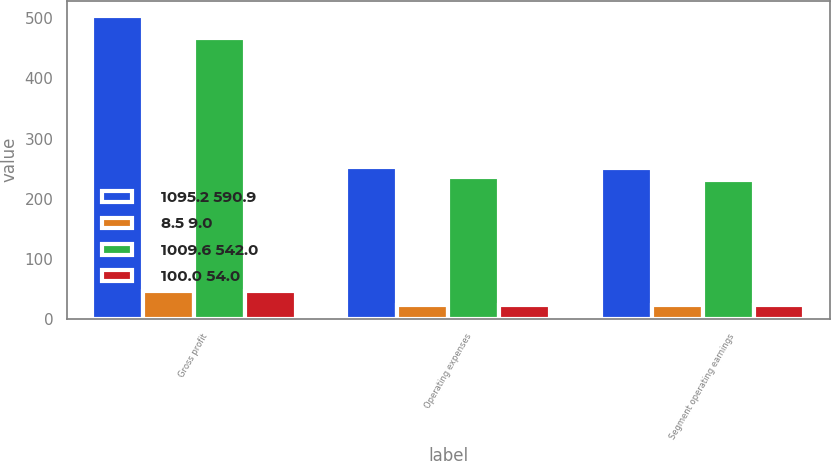Convert chart. <chart><loc_0><loc_0><loc_500><loc_500><stacked_bar_chart><ecel><fcel>Gross profit<fcel>Operating expenses<fcel>Segment operating earnings<nl><fcel>1095.2 590.9<fcel>504.3<fcel>253.1<fcel>251.2<nl><fcel>8.5 9.0<fcel>46<fcel>23.1<fcel>22.9<nl><fcel>1009.6 542.0<fcel>467.6<fcel>235.7<fcel>231.9<nl><fcel>100.0 54.0<fcel>46.3<fcel>23.3<fcel>23<nl></chart> 